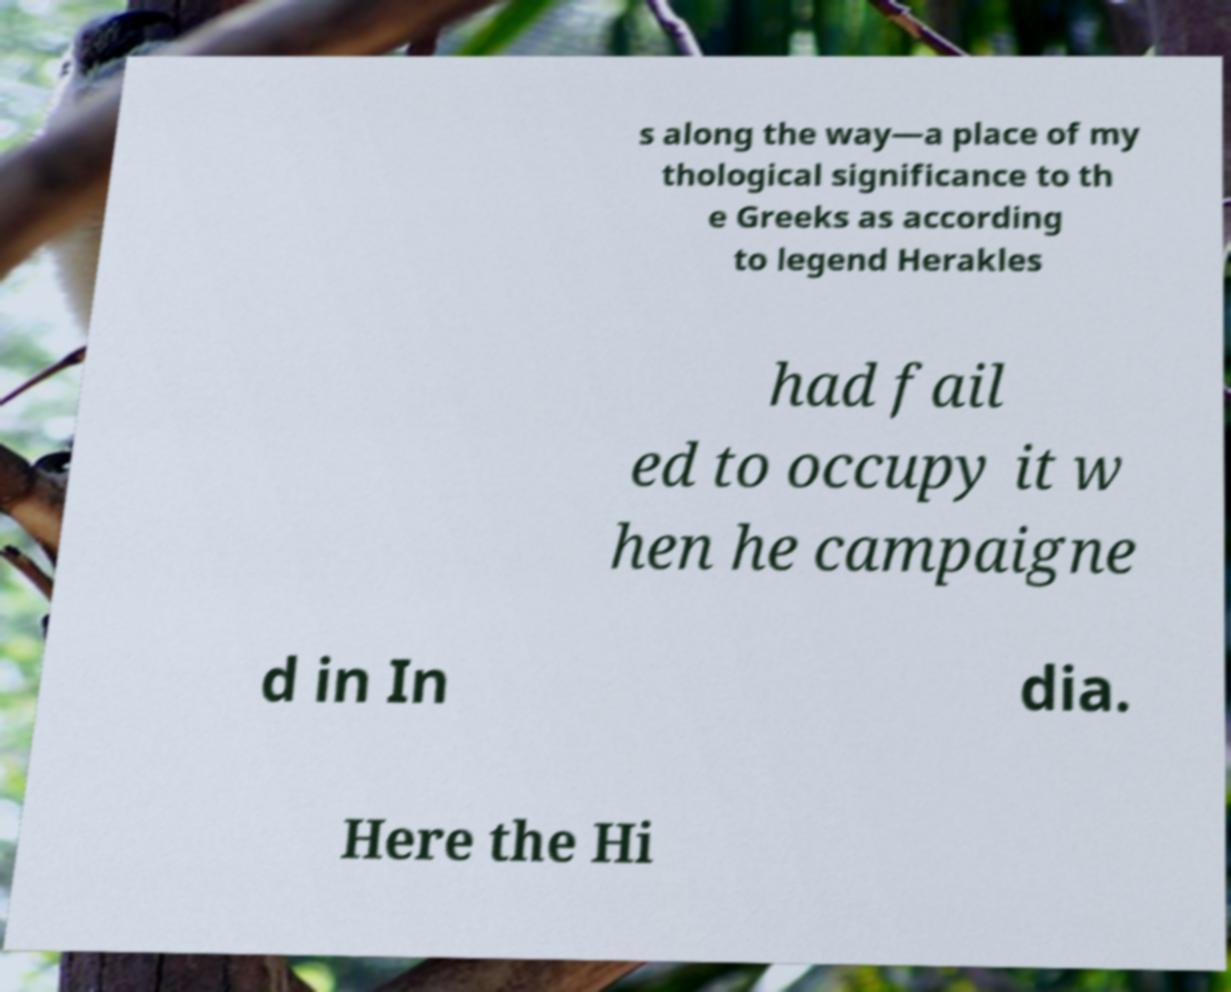For documentation purposes, I need the text within this image transcribed. Could you provide that? s along the way—a place of my thological significance to th e Greeks as according to legend Herakles had fail ed to occupy it w hen he campaigne d in In dia. Here the Hi 